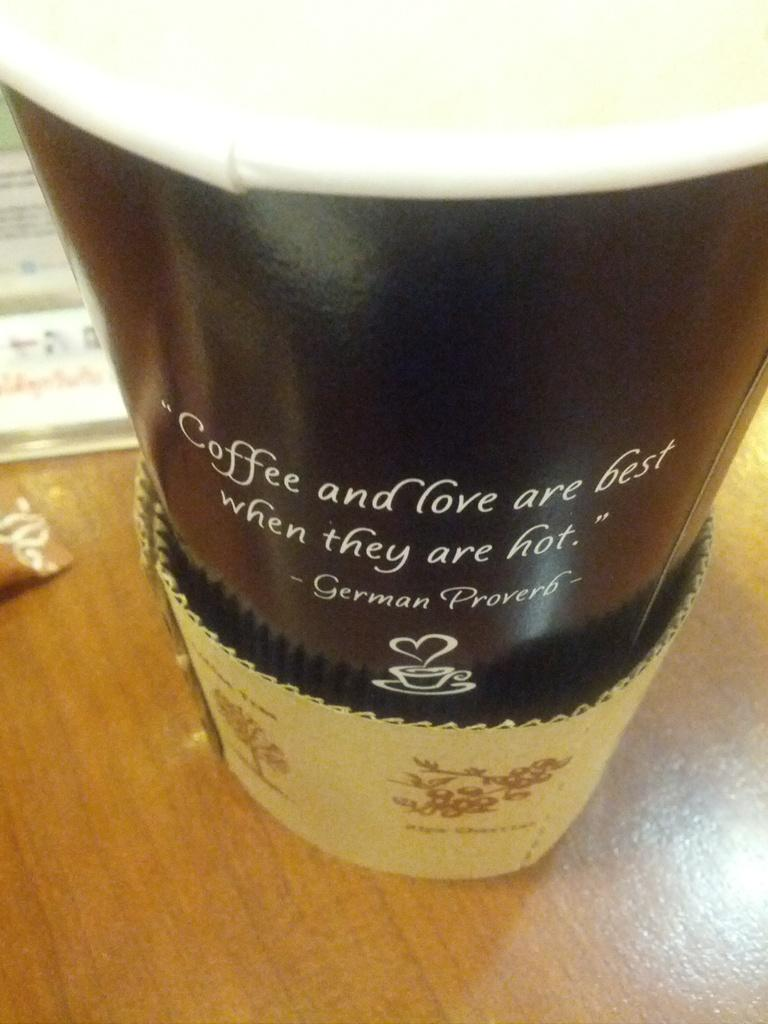<image>
Provide a brief description of the given image. A coffee cup has a German proverb on the side that says, 'Coffee and love are best when they are hot'. 